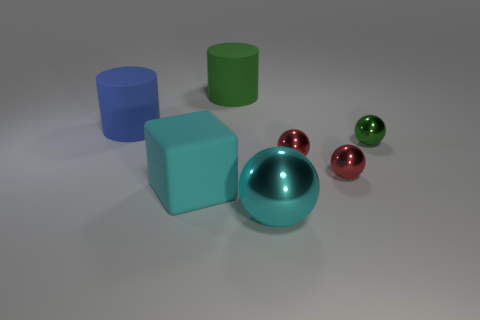Do the green metallic object and the blue rubber thing have the same shape?
Offer a terse response. No. What color is the matte block?
Ensure brevity in your answer.  Cyan. What number of other objects are the same material as the small green object?
Provide a succinct answer. 3. What number of cyan things are either large metal balls or rubber cubes?
Offer a terse response. 2. There is a object in front of the cube; is its shape the same as the matte thing that is right of the cube?
Give a very brief answer. No. There is a big rubber block; is its color the same as the big rubber thing to the right of the cyan cube?
Provide a short and direct response. No. There is a big rubber object that is behind the blue rubber cylinder; does it have the same color as the cube?
Make the answer very short. No. How many things are either red shiny balls or green things behind the green metal ball?
Provide a short and direct response. 3. What is the material of the large object that is in front of the big green object and behind the big cyan cube?
Your answer should be very brief. Rubber. What is the green thing in front of the green matte thing made of?
Offer a terse response. Metal. 